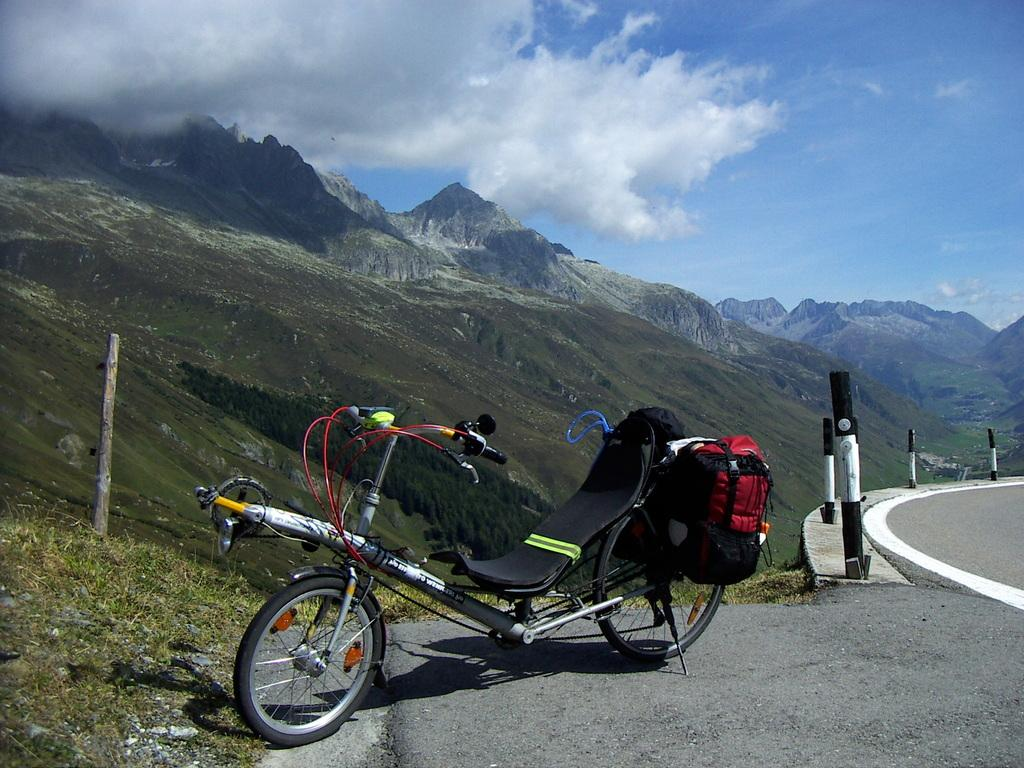What is the main subject in the middle of the image? There is a bicycle in the middle of the image. What can be seen behind the bicycle? There are poles and hills visible behind the bicycle. What is visible at the top of the image? There are clouds visible at the top of the image. What type of collar can be seen on the bicycle in the image? There is no collar present on the bicycle in the image. Can you describe the room where the bicycle is located in the image? The image does not show a room; it is an outdoor scene with hills and clouds visible. 